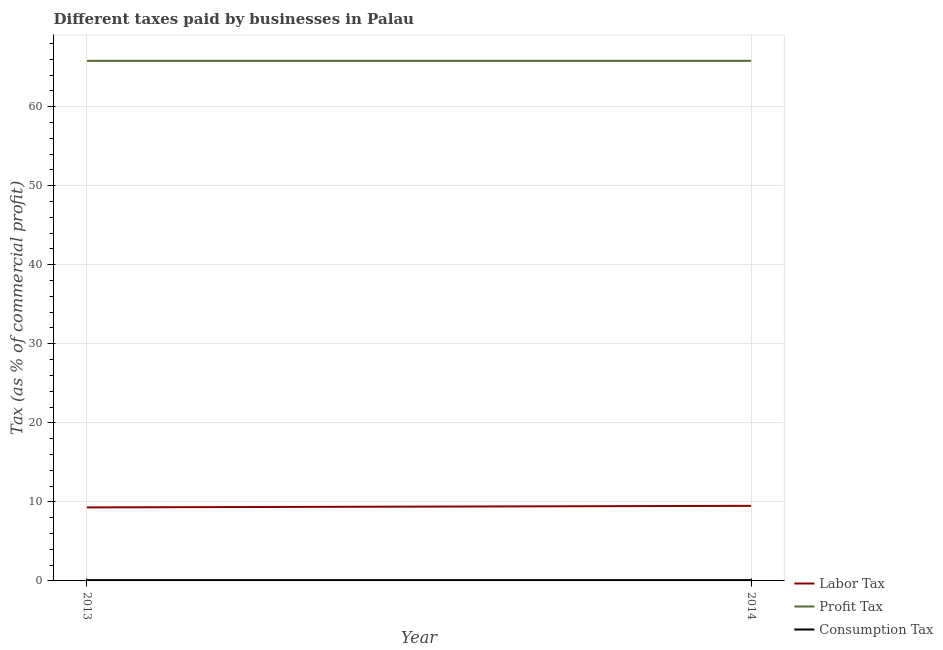Across all years, what is the minimum percentage of profit tax?
Make the answer very short. 65.8. What is the total percentage of profit tax in the graph?
Your response must be concise. 131.6. What is the difference between the percentage of consumption tax in 2013 and that in 2014?
Your response must be concise. 0. What is the difference between the percentage of labor tax in 2013 and the percentage of profit tax in 2014?
Provide a short and direct response. -56.5. What is the average percentage of profit tax per year?
Your answer should be very brief. 65.8. In the year 2013, what is the difference between the percentage of consumption tax and percentage of labor tax?
Make the answer very short. -9.2. Is the percentage of profit tax in 2013 less than that in 2014?
Provide a succinct answer. No. Is it the case that in every year, the sum of the percentage of labor tax and percentage of profit tax is greater than the percentage of consumption tax?
Offer a very short reply. Yes. Does the percentage of labor tax monotonically increase over the years?
Keep it short and to the point. Yes. Is the percentage of consumption tax strictly greater than the percentage of labor tax over the years?
Ensure brevity in your answer.  No. Is the percentage of profit tax strictly less than the percentage of labor tax over the years?
Your answer should be very brief. No. What is the title of the graph?
Make the answer very short. Different taxes paid by businesses in Palau. What is the label or title of the X-axis?
Your answer should be very brief. Year. What is the label or title of the Y-axis?
Provide a succinct answer. Tax (as % of commercial profit). What is the Tax (as % of commercial profit) in Profit Tax in 2013?
Ensure brevity in your answer.  65.8. What is the Tax (as % of commercial profit) in Consumption Tax in 2013?
Provide a short and direct response. 0.1. What is the Tax (as % of commercial profit) of Profit Tax in 2014?
Offer a terse response. 65.8. What is the Tax (as % of commercial profit) in Consumption Tax in 2014?
Your answer should be very brief. 0.1. Across all years, what is the maximum Tax (as % of commercial profit) in Labor Tax?
Ensure brevity in your answer.  9.5. Across all years, what is the maximum Tax (as % of commercial profit) of Profit Tax?
Ensure brevity in your answer.  65.8. Across all years, what is the minimum Tax (as % of commercial profit) in Profit Tax?
Keep it short and to the point. 65.8. Across all years, what is the minimum Tax (as % of commercial profit) in Consumption Tax?
Offer a terse response. 0.1. What is the total Tax (as % of commercial profit) in Profit Tax in the graph?
Provide a short and direct response. 131.6. What is the total Tax (as % of commercial profit) in Consumption Tax in the graph?
Provide a short and direct response. 0.2. What is the difference between the Tax (as % of commercial profit) in Labor Tax in 2013 and that in 2014?
Give a very brief answer. -0.2. What is the difference between the Tax (as % of commercial profit) in Consumption Tax in 2013 and that in 2014?
Your answer should be very brief. 0. What is the difference between the Tax (as % of commercial profit) in Labor Tax in 2013 and the Tax (as % of commercial profit) in Profit Tax in 2014?
Make the answer very short. -56.5. What is the difference between the Tax (as % of commercial profit) of Labor Tax in 2013 and the Tax (as % of commercial profit) of Consumption Tax in 2014?
Offer a very short reply. 9.2. What is the difference between the Tax (as % of commercial profit) in Profit Tax in 2013 and the Tax (as % of commercial profit) in Consumption Tax in 2014?
Provide a short and direct response. 65.7. What is the average Tax (as % of commercial profit) of Profit Tax per year?
Keep it short and to the point. 65.8. In the year 2013, what is the difference between the Tax (as % of commercial profit) of Labor Tax and Tax (as % of commercial profit) of Profit Tax?
Offer a terse response. -56.5. In the year 2013, what is the difference between the Tax (as % of commercial profit) of Profit Tax and Tax (as % of commercial profit) of Consumption Tax?
Your response must be concise. 65.7. In the year 2014, what is the difference between the Tax (as % of commercial profit) in Labor Tax and Tax (as % of commercial profit) in Profit Tax?
Your answer should be compact. -56.3. In the year 2014, what is the difference between the Tax (as % of commercial profit) of Labor Tax and Tax (as % of commercial profit) of Consumption Tax?
Your answer should be compact. 9.4. In the year 2014, what is the difference between the Tax (as % of commercial profit) of Profit Tax and Tax (as % of commercial profit) of Consumption Tax?
Give a very brief answer. 65.7. What is the ratio of the Tax (as % of commercial profit) in Labor Tax in 2013 to that in 2014?
Provide a succinct answer. 0.98. What is the ratio of the Tax (as % of commercial profit) in Profit Tax in 2013 to that in 2014?
Offer a terse response. 1. What is the ratio of the Tax (as % of commercial profit) in Consumption Tax in 2013 to that in 2014?
Your answer should be compact. 1. What is the difference between the highest and the second highest Tax (as % of commercial profit) of Labor Tax?
Provide a succinct answer. 0.2. What is the difference between the highest and the second highest Tax (as % of commercial profit) in Profit Tax?
Ensure brevity in your answer.  0. What is the difference between the highest and the lowest Tax (as % of commercial profit) of Consumption Tax?
Make the answer very short. 0. 